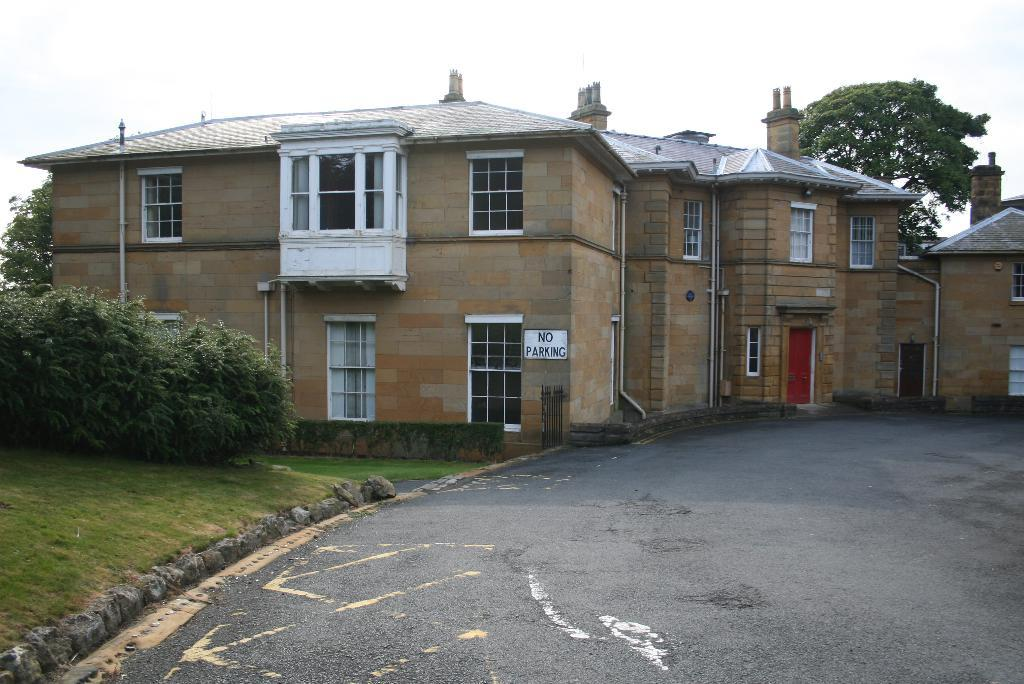What type of structures can be seen in the image? There are buildings in the image. What else can be seen in the image besides the buildings? Pipelines, windows, trees, the sky with clouds, bushes, the ground, stones, and a road are present in the image. Can you describe the natural elements in the image? Trees, bushes, and the sky with clouds are the natural elements visible in the image. What type of surface is visible in the image? The ground is visible in the image. What man-made feature can be seen in the image? There is a road in the image. What type of vase is placed on the road in the image? There is no vase present in the image; it only features buildings, pipelines, windows, trees, the sky with clouds, bushes, the ground, stones, and a road. How many crates are visible in the image? There are no crates present in the image. 